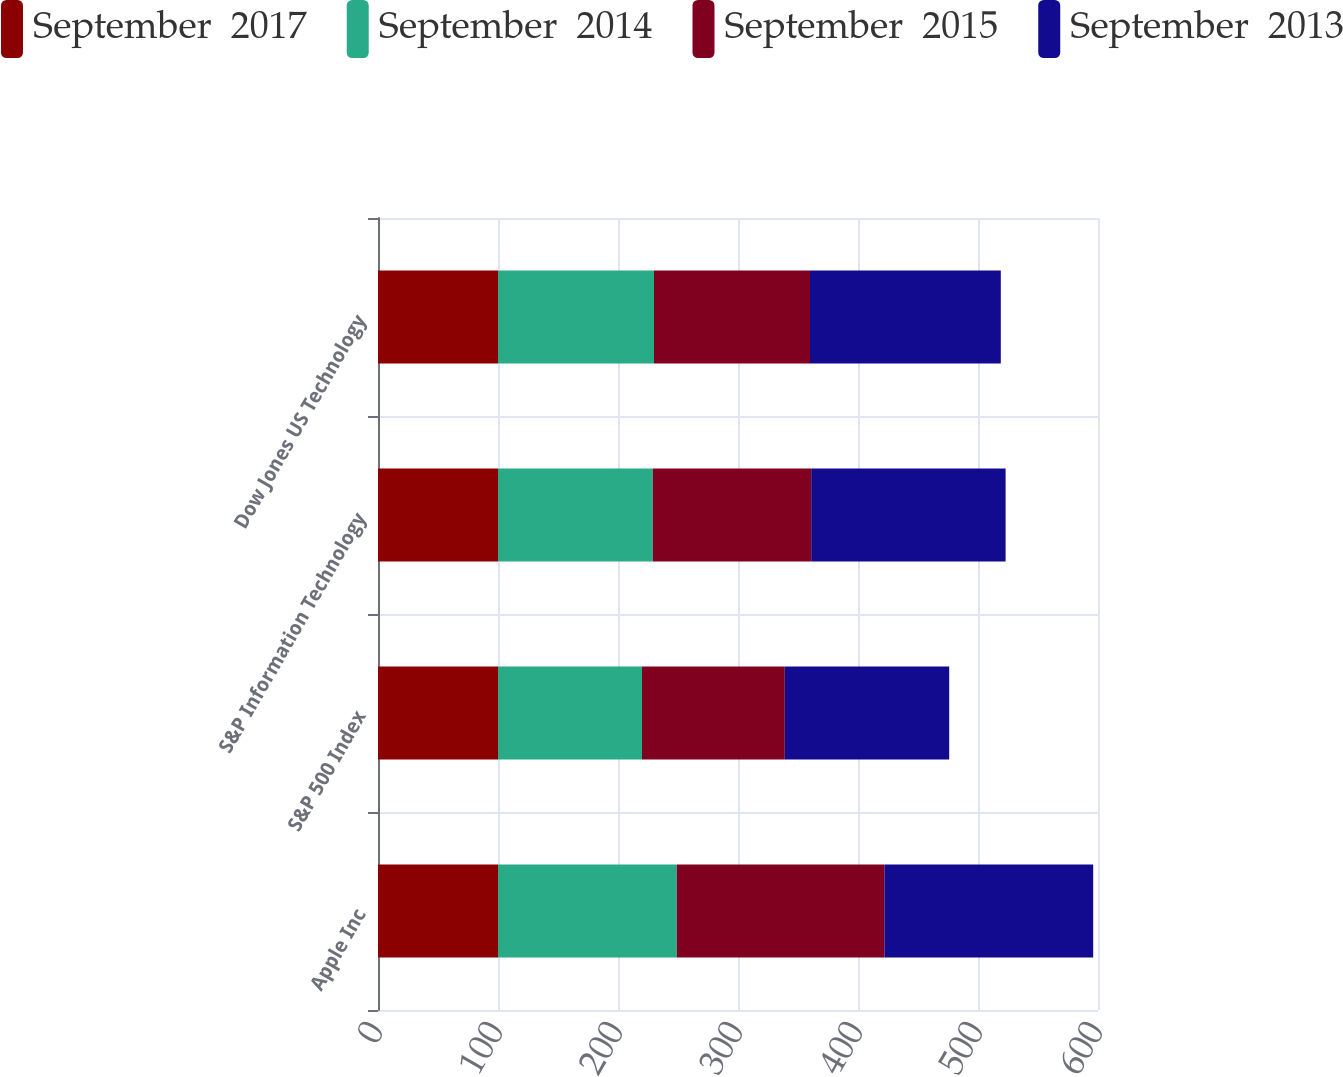Convert chart to OTSL. <chart><loc_0><loc_0><loc_500><loc_500><stacked_bar_chart><ecel><fcel>Apple Inc<fcel>S&P 500 Index<fcel>S&P Information Technology<fcel>Dow Jones US Technology<nl><fcel>September  2017<fcel>100<fcel>100<fcel>100<fcel>100<nl><fcel>September  2014<fcel>149<fcel>120<fcel>129<fcel>130<nl><fcel>September  2015<fcel>173<fcel>119<fcel>132<fcel>130<nl><fcel>September  2013<fcel>174<fcel>137<fcel>162<fcel>159<nl></chart> 